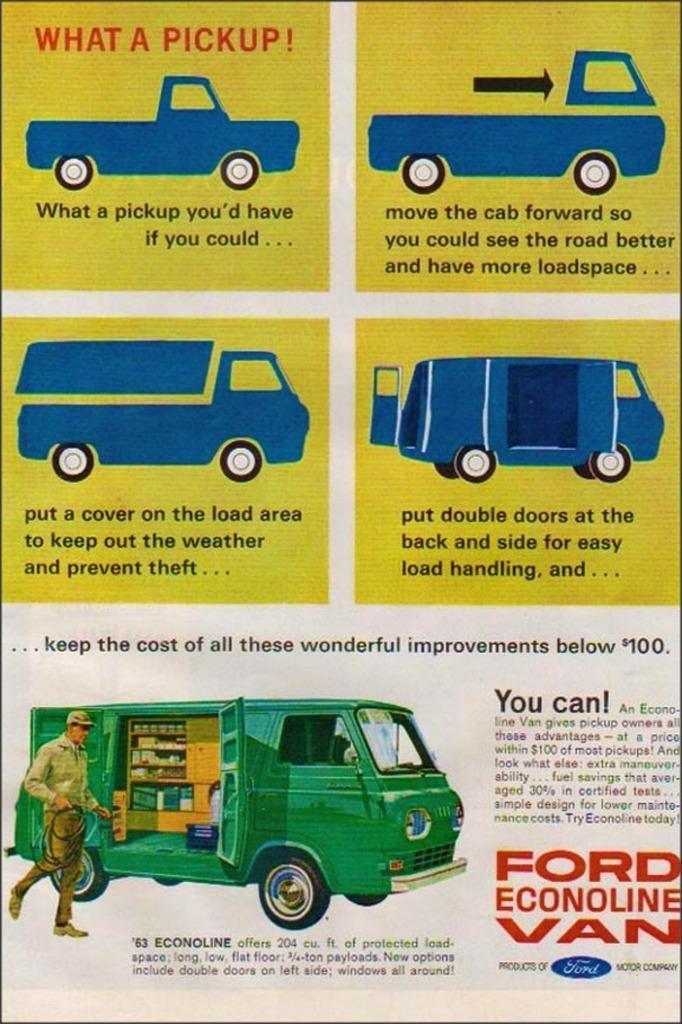Could you give a brief overview of what you see in this image? In the image there is a poster with images of trucks and text below it. 